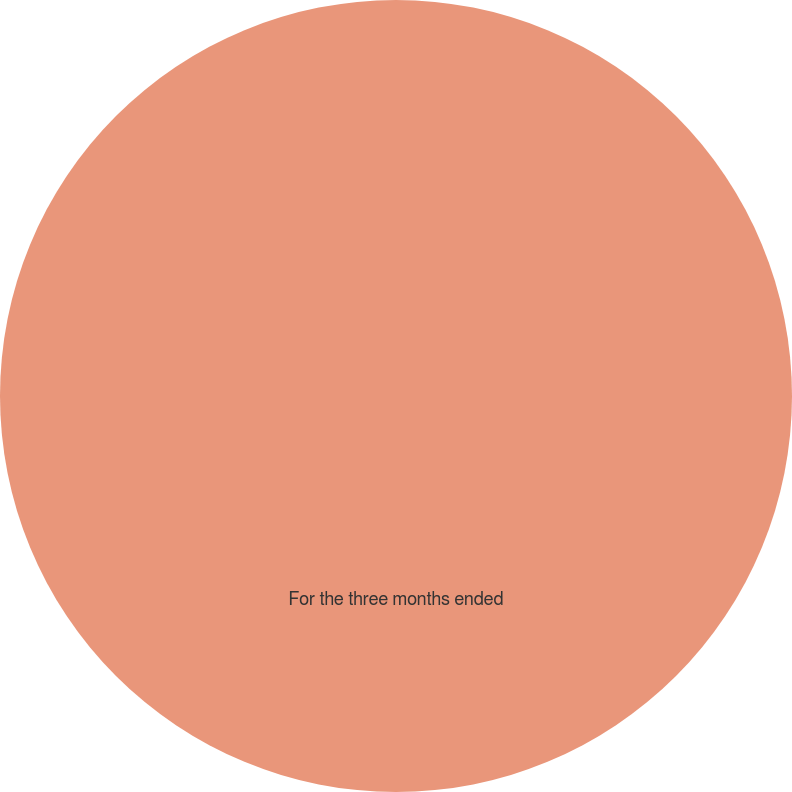<chart> <loc_0><loc_0><loc_500><loc_500><pie_chart><fcel>For the three months ended<nl><fcel>100.0%<nl></chart> 